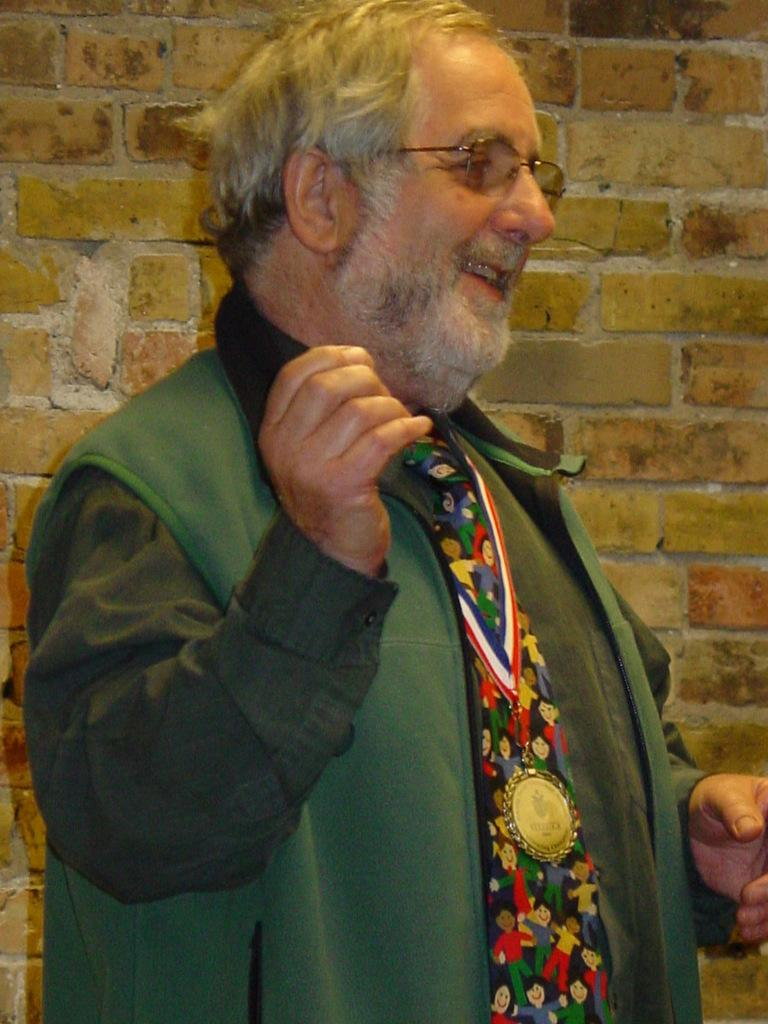What is the main subject of the image? There is a man standing in the front of the image. What is the man doing in the image? The man is smiling in the image. What can be seen in the background of the image? There is a wall in the background of the image. Can you see any frogs hopping around in the image? There are no frogs present in the image. What type of clover is growing on the man's head in the image? There is no clover visible in the image, and the man's head is not shown. 